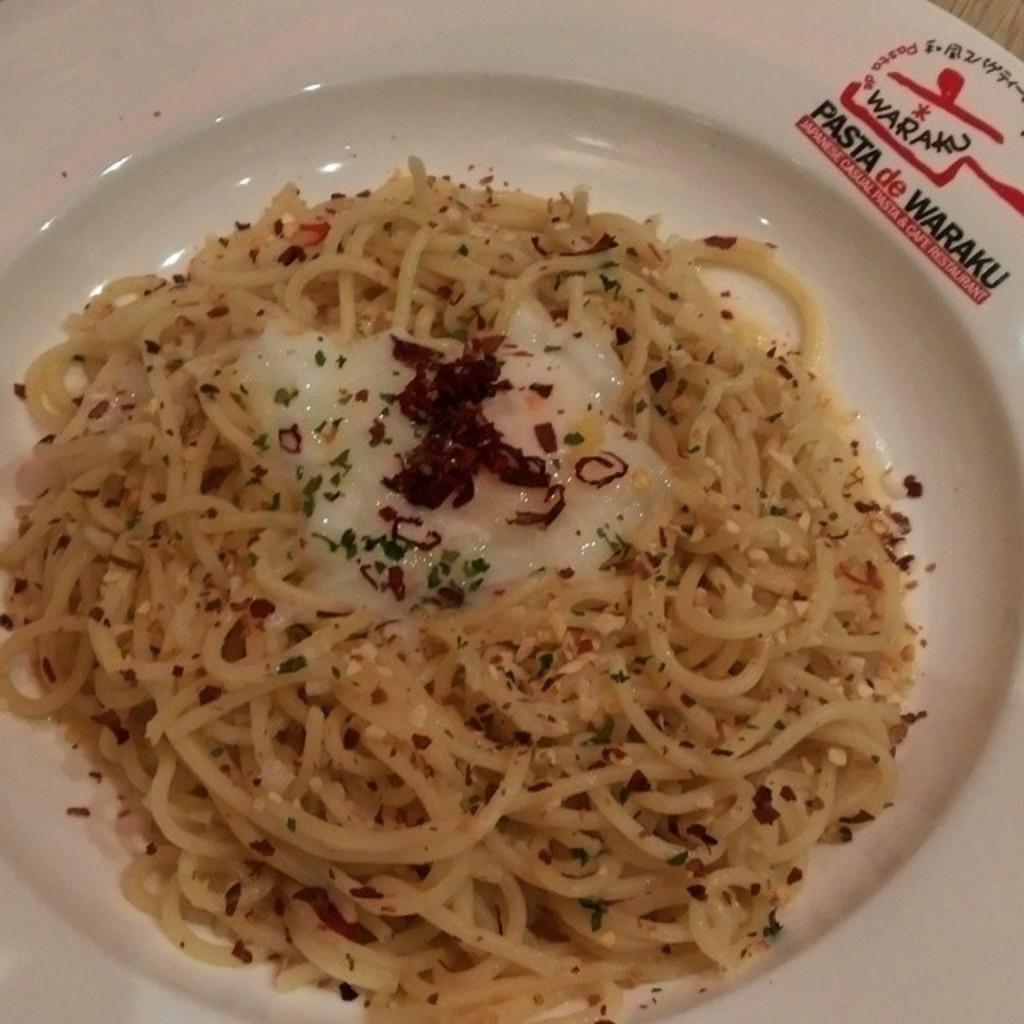What type of furniture is present in the image? There is a table in the image. What can be found on the table? There are food items on the table. Can you describe a specific item on the table? There is text on a plate in the image. How many men are visible in the image? There are no men present in the image. What type of arm is visible in the image? There are no arms visible in the image. 